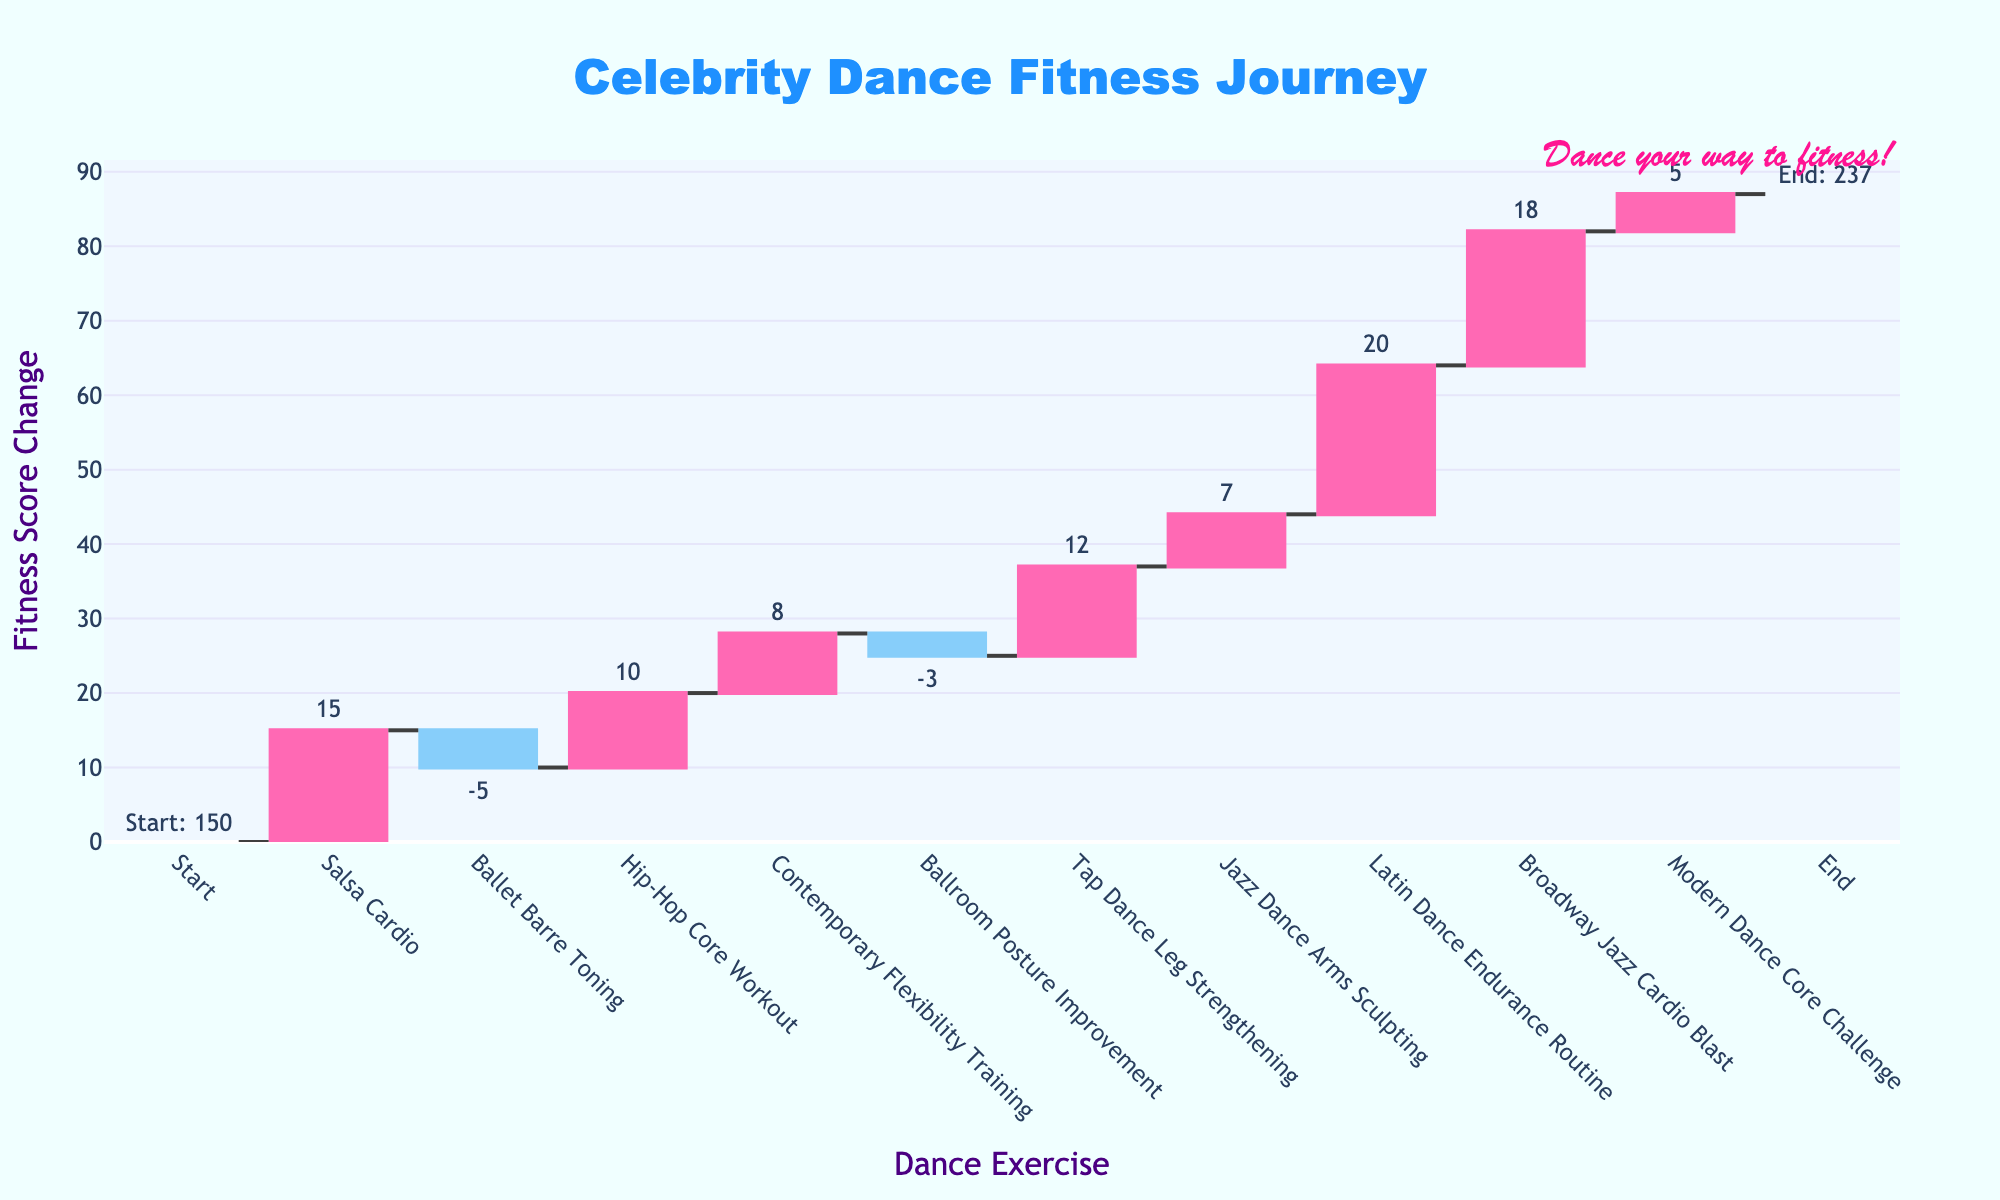What is the title of the chart? The title is usually shown at the top of the chart and typically summarizes what the chart is about. In this case, the title is "Celebrity Dance Fitness Journey".
Answer: Celebrity Dance Fitness Journey Which dance-focused exercise resulted in the highest increase in fitness score? To determine the exercise with the highest increase, look for the bar with the greatest positive change, indicated by a pink bar. The "Latin Dance Endurance Routine" saw the highest increase of +20.
Answer: Latin Dance Endurance Routine What is the overall change in fitness score from the start to the end? Subtract the starting fitness score (150) from the ending fitness score (237). So, 237 - 150 = 87.
Answer: 87 How many activities led to a decrease in the fitness score? Look for the blue bars that represent a decrease in fitness score. There are two such bars: "Ballet Barre Toning" (-5) and "Ballroom Posture Improvement" (-3).
Answer: 2 What is the fitness score change after the "Broadway Jazz Cardio Blast"? Check the running total after the "Broadway Jazz Cardio Blast". The fitness score changes to 232.
Answer: 232 What was the impact of "Hip-Hop Core Workout" on the fitness score? Identify the specific bar for "Hip-Hop Core Workout". It shows an increase of +10 in the fitness score.
Answer: +10 Which dance exercise had the smallest positive change in fitness score, and what was the value? Among the pink bars, the smallest positive change in fitness score is +5, which is due to "Modern Dance Core Challenge".
Answer: Modern Dance Core Challenge, +5 What is the cumulative fitness score change after the "Tap Dance Leg Strengthening"? Add up the incremental changes from the start to the end of "Tap Dance Leg Strengthening". The cumulative fitness score is 187.
Answer: 187 How does the fitness score change due to "Jazz Dance Arms Sculpting" compare to "Contemporary Flexibility Training"? Compare the pink bars for both exercises. "Jazz Dance Arms Sculpting" had a fitness score increase of +7, while "Contemporary Flexibility Training" had an increase of +8.
Answer: Contemporary Flexibility Training had a larger impact (+8) compared to Jazz Dance Arms Sculpting (+7) What is the fitness score before the "Ballet Barre Toning" session, and what is it after? The fitness score before "Ballet Barre Toning" is 165 and after it is 160, leading to a decrease of 5.
Answer: Before: 165, After: 160 